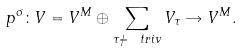<formula> <loc_0><loc_0><loc_500><loc_500>p ^ { \sigma } \colon V = V ^ { M } \oplus \sum _ { \tau \ne \ t r i v } V _ { \tau } \rightarrow V ^ { M } .</formula> 